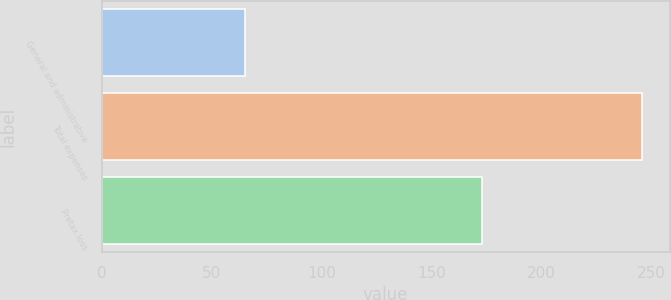Convert chart to OTSL. <chart><loc_0><loc_0><loc_500><loc_500><bar_chart><fcel>General and administrative<fcel>Total expenses<fcel>Pretax loss<nl><fcel>65<fcel>246<fcel>173<nl></chart> 